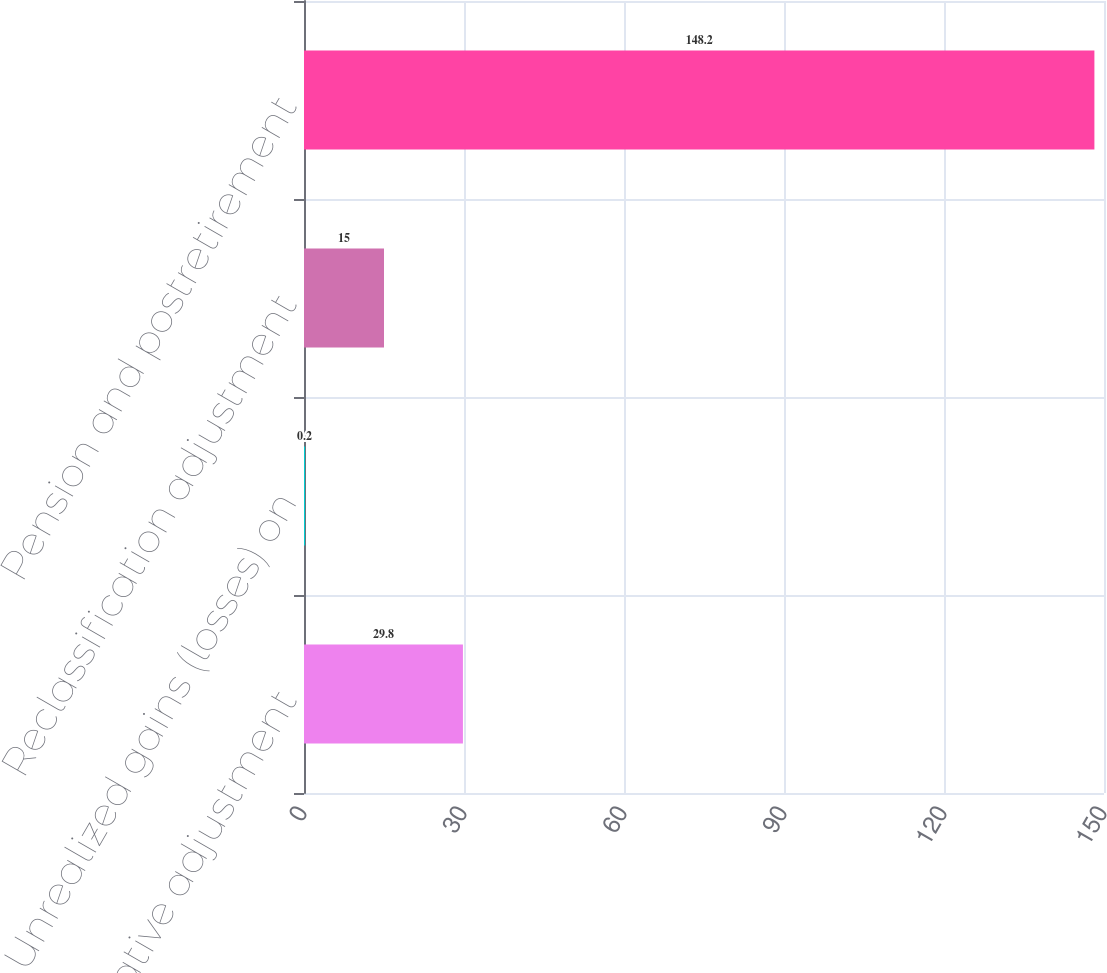Convert chart. <chart><loc_0><loc_0><loc_500><loc_500><bar_chart><fcel>Net derivative adjustment<fcel>Unrealized gains (losses) on<fcel>Reclassification adjustment<fcel>Pension and postretirement<nl><fcel>29.8<fcel>0.2<fcel>15<fcel>148.2<nl></chart> 